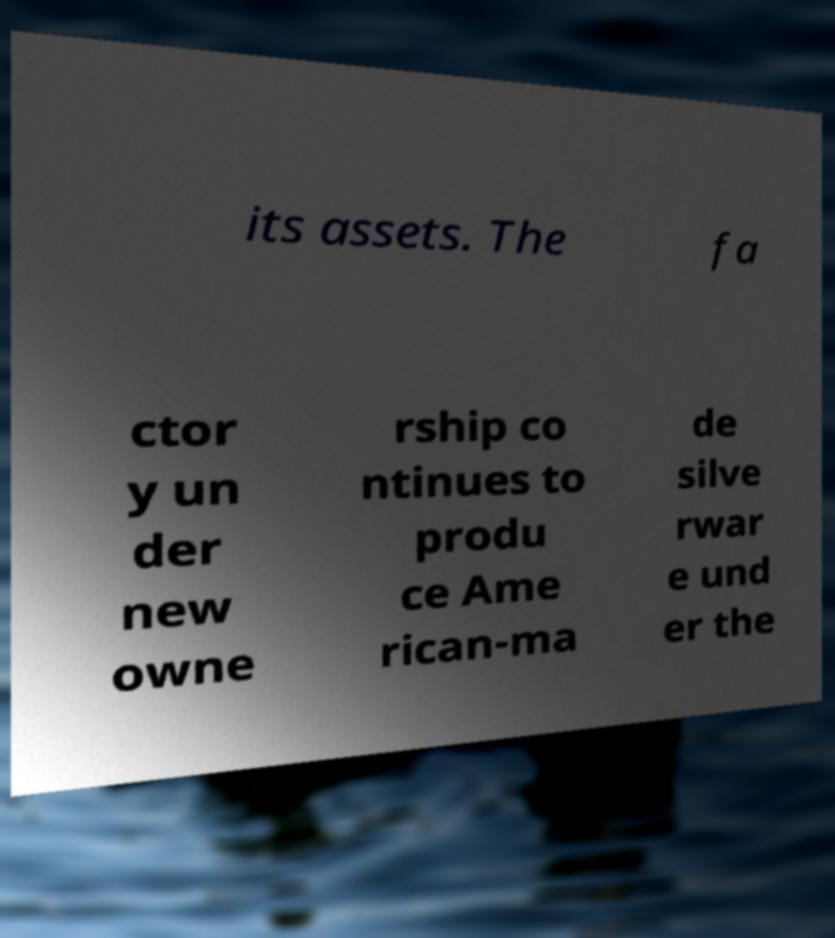I need the written content from this picture converted into text. Can you do that? its assets. The fa ctor y un der new owne rship co ntinues to produ ce Ame rican-ma de silve rwar e und er the 